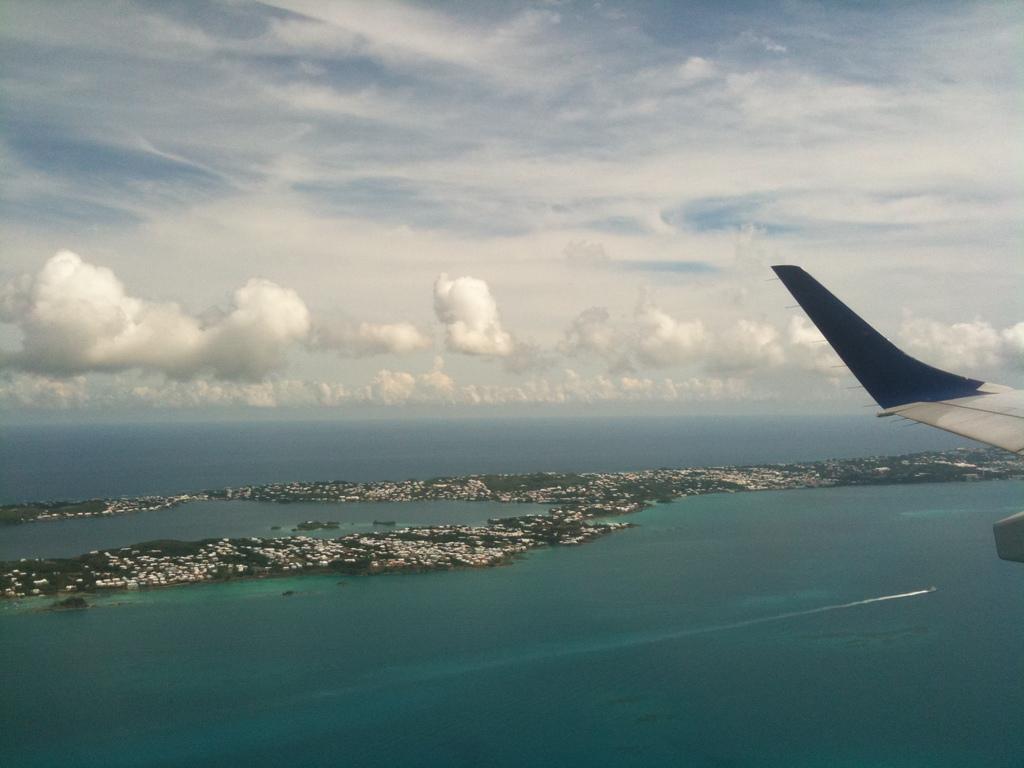Describe this image in one or two sentences. In this picture we can see an airplane tail, water, some objects and in the background we can see the sky with clouds. 